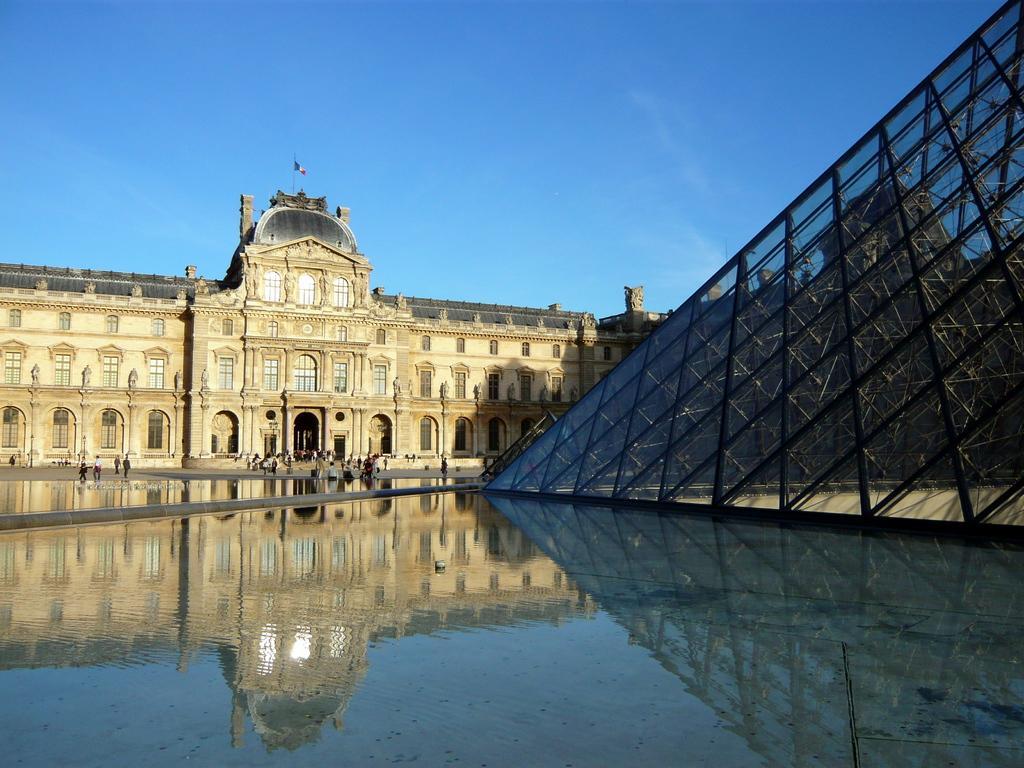Could you give a brief overview of what you see in this image? At the bottom of the image there is water. In the background of the image there is a building. There are people. At the top of the image there is sky. To the right side of the image there is glass structure. 